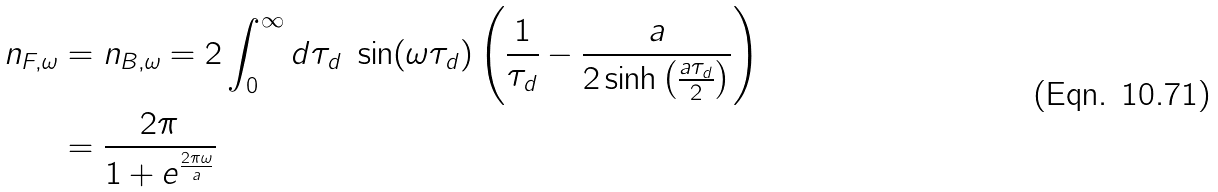<formula> <loc_0><loc_0><loc_500><loc_500>n _ { F , \omega } & = n _ { B , \omega } = 2 \int _ { 0 } ^ { \infty } d \tau _ { d } \ \sin ( \omega \tau _ { d } ) \left ( \frac { 1 } { \tau _ { d } } - \frac { a } { 2 \sinh \left ( \frac { a \tau _ { d } } { 2 } \right ) } \right ) \\ & = \frac { 2 \pi } { 1 + e ^ { \frac { 2 \pi \omega } { a } } }</formula> 